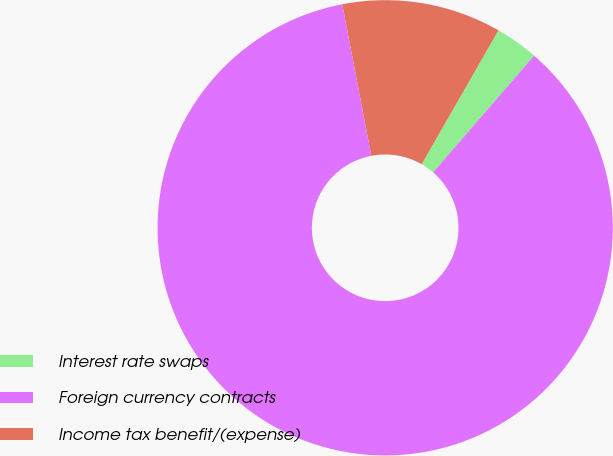Convert chart to OTSL. <chart><loc_0><loc_0><loc_500><loc_500><pie_chart><fcel>Interest rate swaps<fcel>Foreign currency contracts<fcel>Income tax benefit/(expense)<nl><fcel>3.06%<fcel>85.63%<fcel>11.31%<nl></chart> 